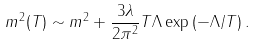Convert formula to latex. <formula><loc_0><loc_0><loc_500><loc_500>m ^ { 2 } ( T ) \sim m ^ { 2 } + \frac { 3 \lambda } { 2 \pi ^ { 2 } } T \Lambda \exp \left ( - \Lambda / T \right ) .</formula> 